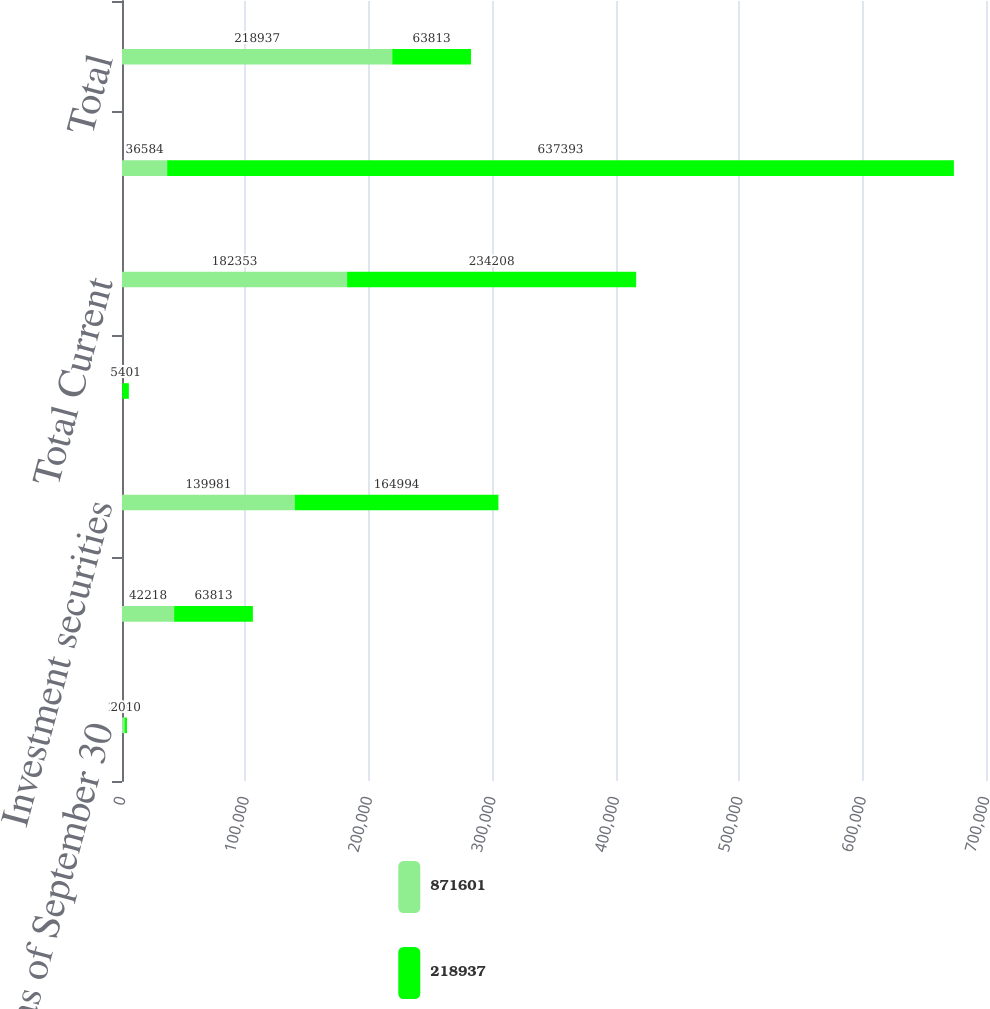Convert chart to OTSL. <chart><loc_0><loc_0><loc_500><loc_500><stacked_bar_chart><ecel><fcel>as of September 30<fcel>Receivables<fcel>Investment securities<fcel>Investments in equity method<fcel>Total Current<fcel>Total Non-Current<fcel>Total<nl><fcel>871601<fcel>2011<fcel>42218<fcel>139981<fcel>154<fcel>182353<fcel>36584<fcel>218937<nl><fcel>218937<fcel>2010<fcel>63813<fcel>164994<fcel>5401<fcel>234208<fcel>637393<fcel>63813<nl></chart> 